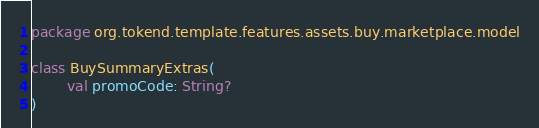<code> <loc_0><loc_0><loc_500><loc_500><_Kotlin_>package org.tokend.template.features.assets.buy.marketplace.model

class BuySummaryExtras(
        val promoCode: String?
)</code> 